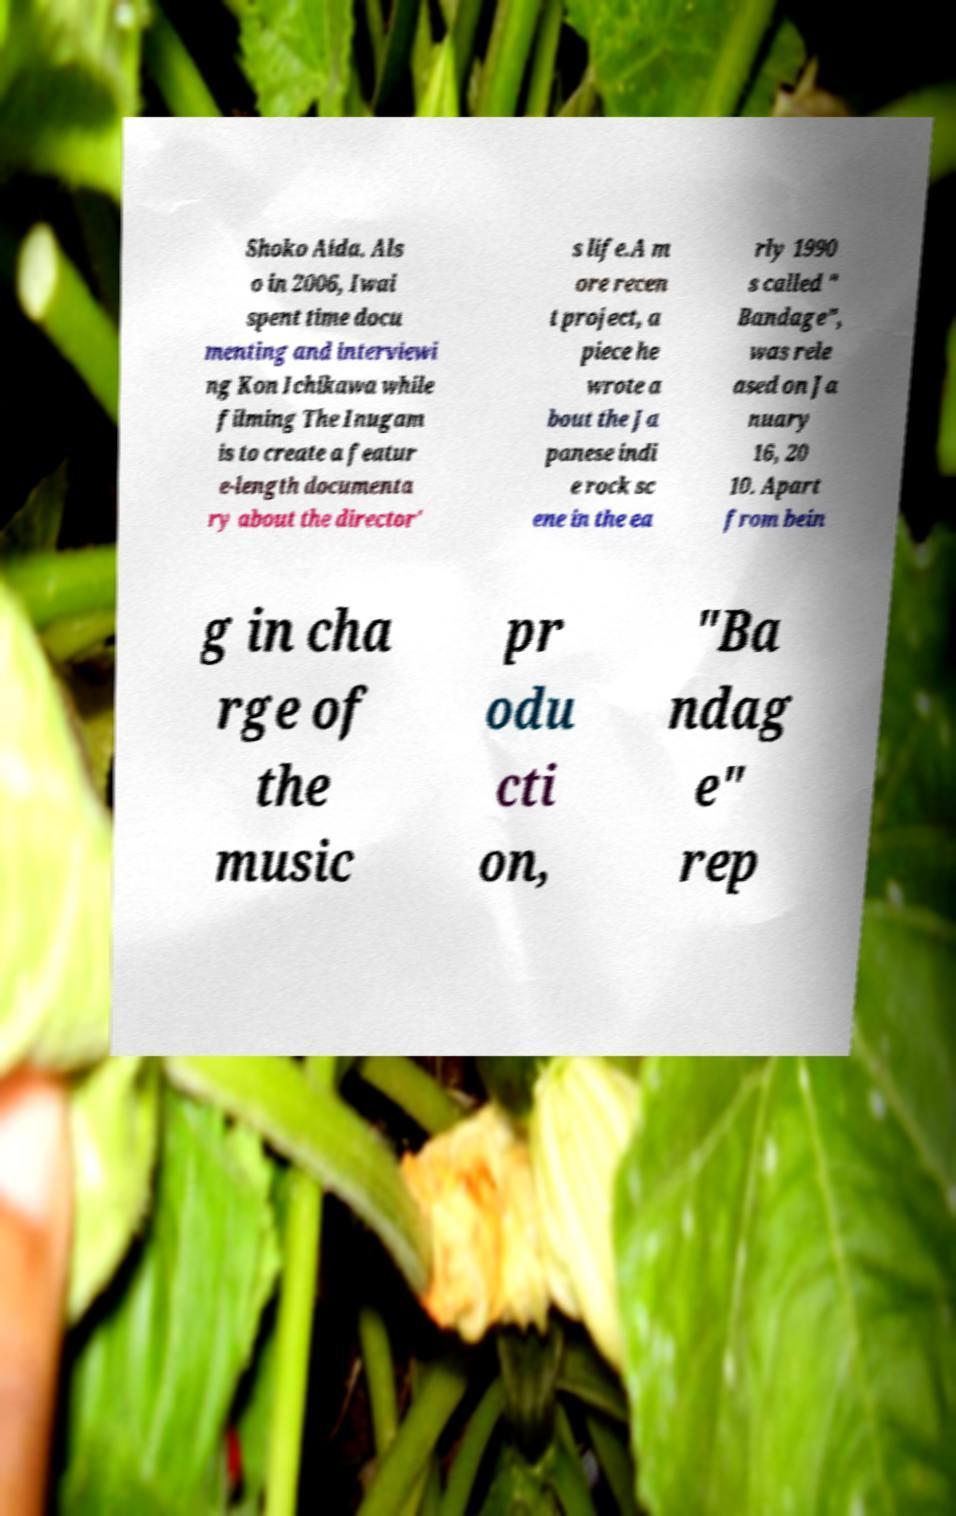Could you extract and type out the text from this image? Shoko Aida. Als o in 2006, Iwai spent time docu menting and interviewi ng Kon Ichikawa while filming The Inugam is to create a featur e-length documenta ry about the director' s life.A m ore recen t project, a piece he wrote a bout the Ja panese indi e rock sc ene in the ea rly 1990 s called " Bandage", was rele ased on Ja nuary 16, 20 10. Apart from bein g in cha rge of the music pr odu cti on, "Ba ndag e" rep 